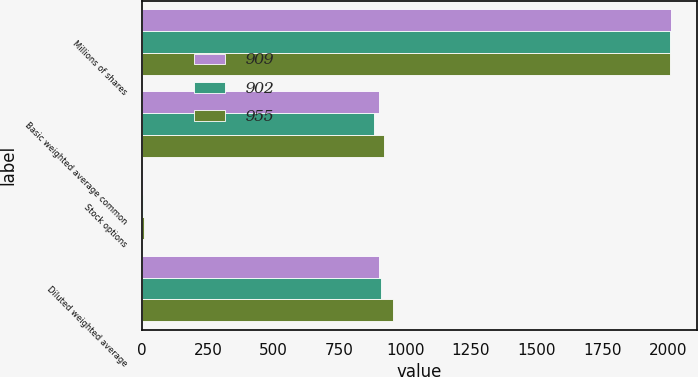<chart> <loc_0><loc_0><loc_500><loc_500><stacked_bar_chart><ecel><fcel>Millions of shares<fcel>Basic weighted average common<fcel>Stock options<fcel>Diluted weighted average<nl><fcel>909<fcel>2009<fcel>900<fcel>2<fcel>902<nl><fcel>902<fcel>2008<fcel>883<fcel>4<fcel>909<nl><fcel>955<fcel>2007<fcel>919<fcel>7<fcel>955<nl></chart> 